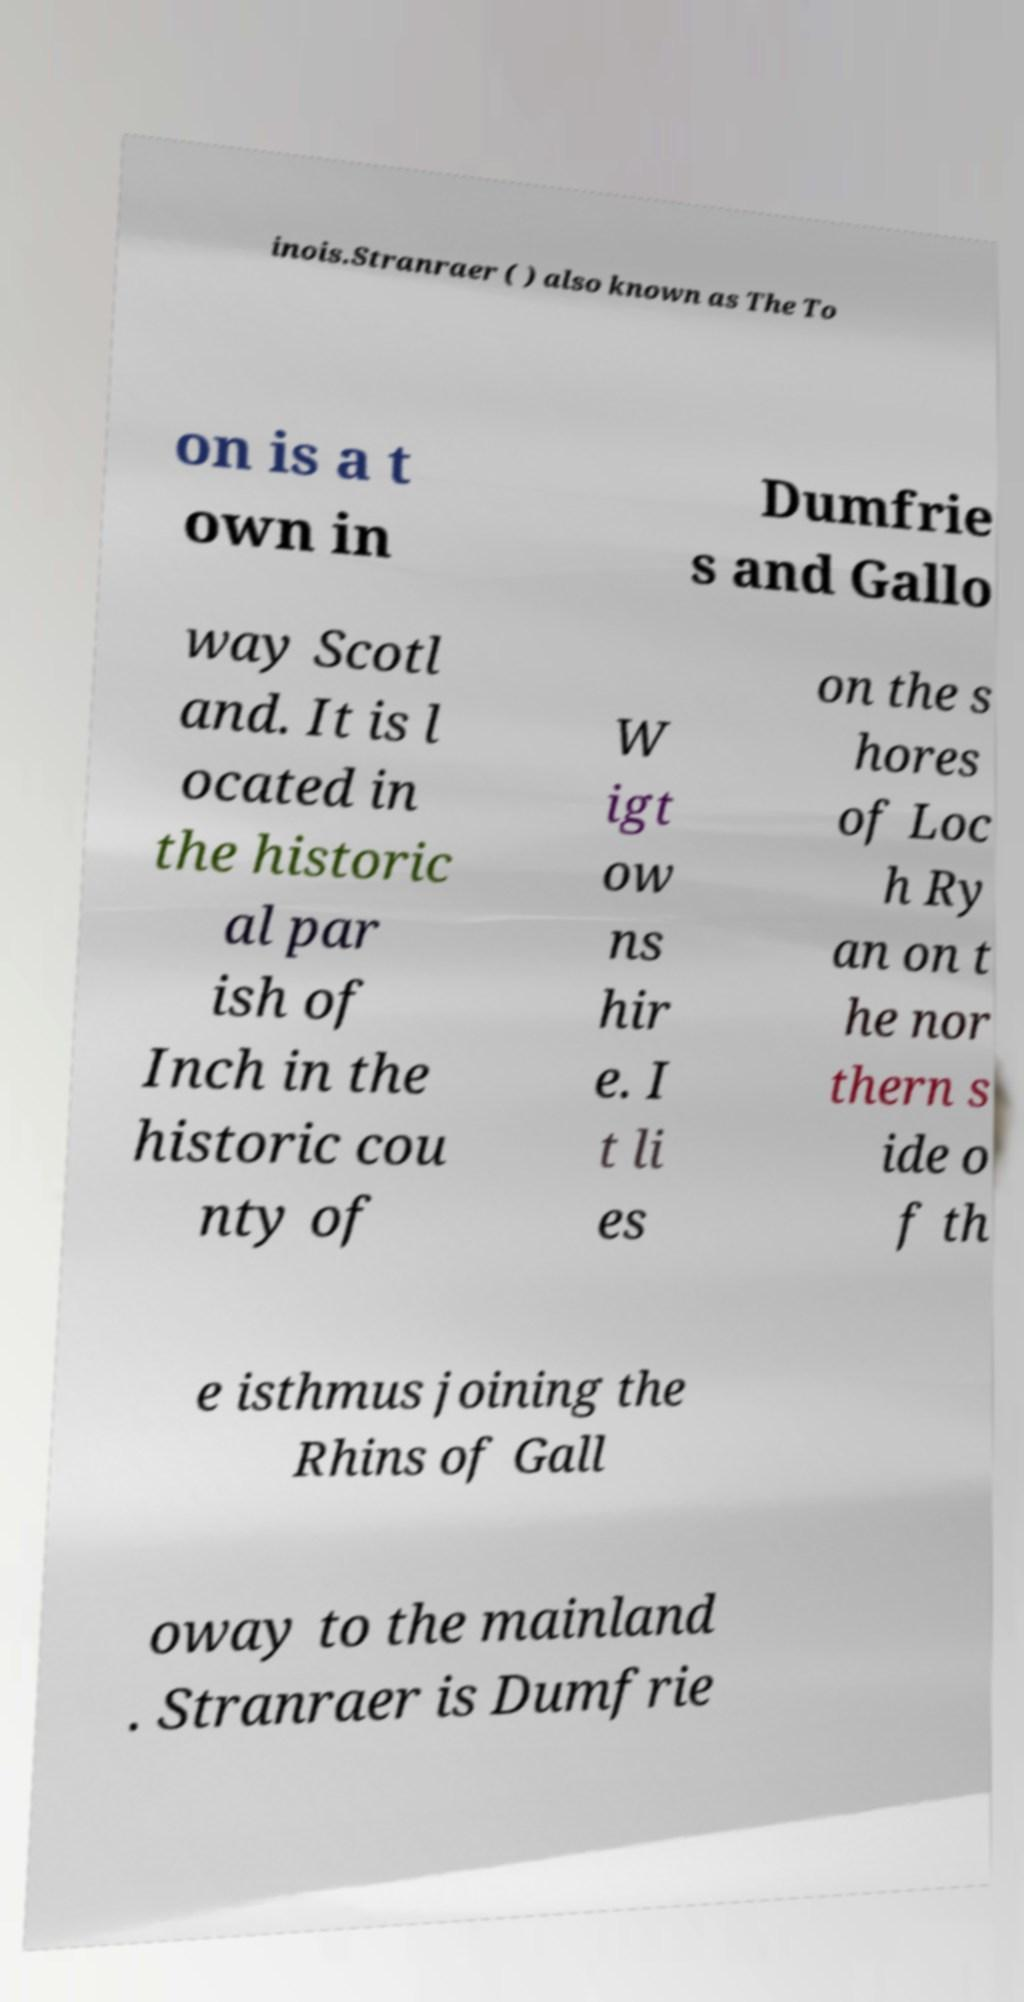Could you extract and type out the text from this image? inois.Stranraer ( ) also known as The To on is a t own in Dumfrie s and Gallo way Scotl and. It is l ocated in the historic al par ish of Inch in the historic cou nty of W igt ow ns hir e. I t li es on the s hores of Loc h Ry an on t he nor thern s ide o f th e isthmus joining the Rhins of Gall oway to the mainland . Stranraer is Dumfrie 